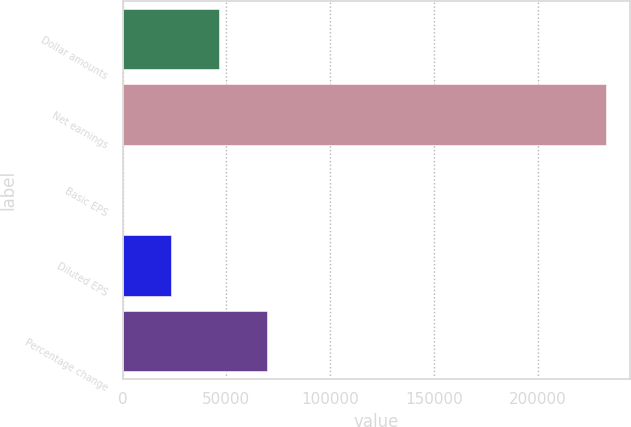Convert chart. <chart><loc_0><loc_0><loc_500><loc_500><bar_chart><fcel>Dollar amounts<fcel>Net earnings<fcel>Basic EPS<fcel>Diluted EPS<fcel>Percentage change<nl><fcel>46525.7<fcel>232622<fcel>1.55<fcel>23263.6<fcel>69787.7<nl></chart> 